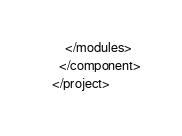Convert code to text. <code><loc_0><loc_0><loc_500><loc_500><_XML_>    </modules>
  </component>
</project></code> 